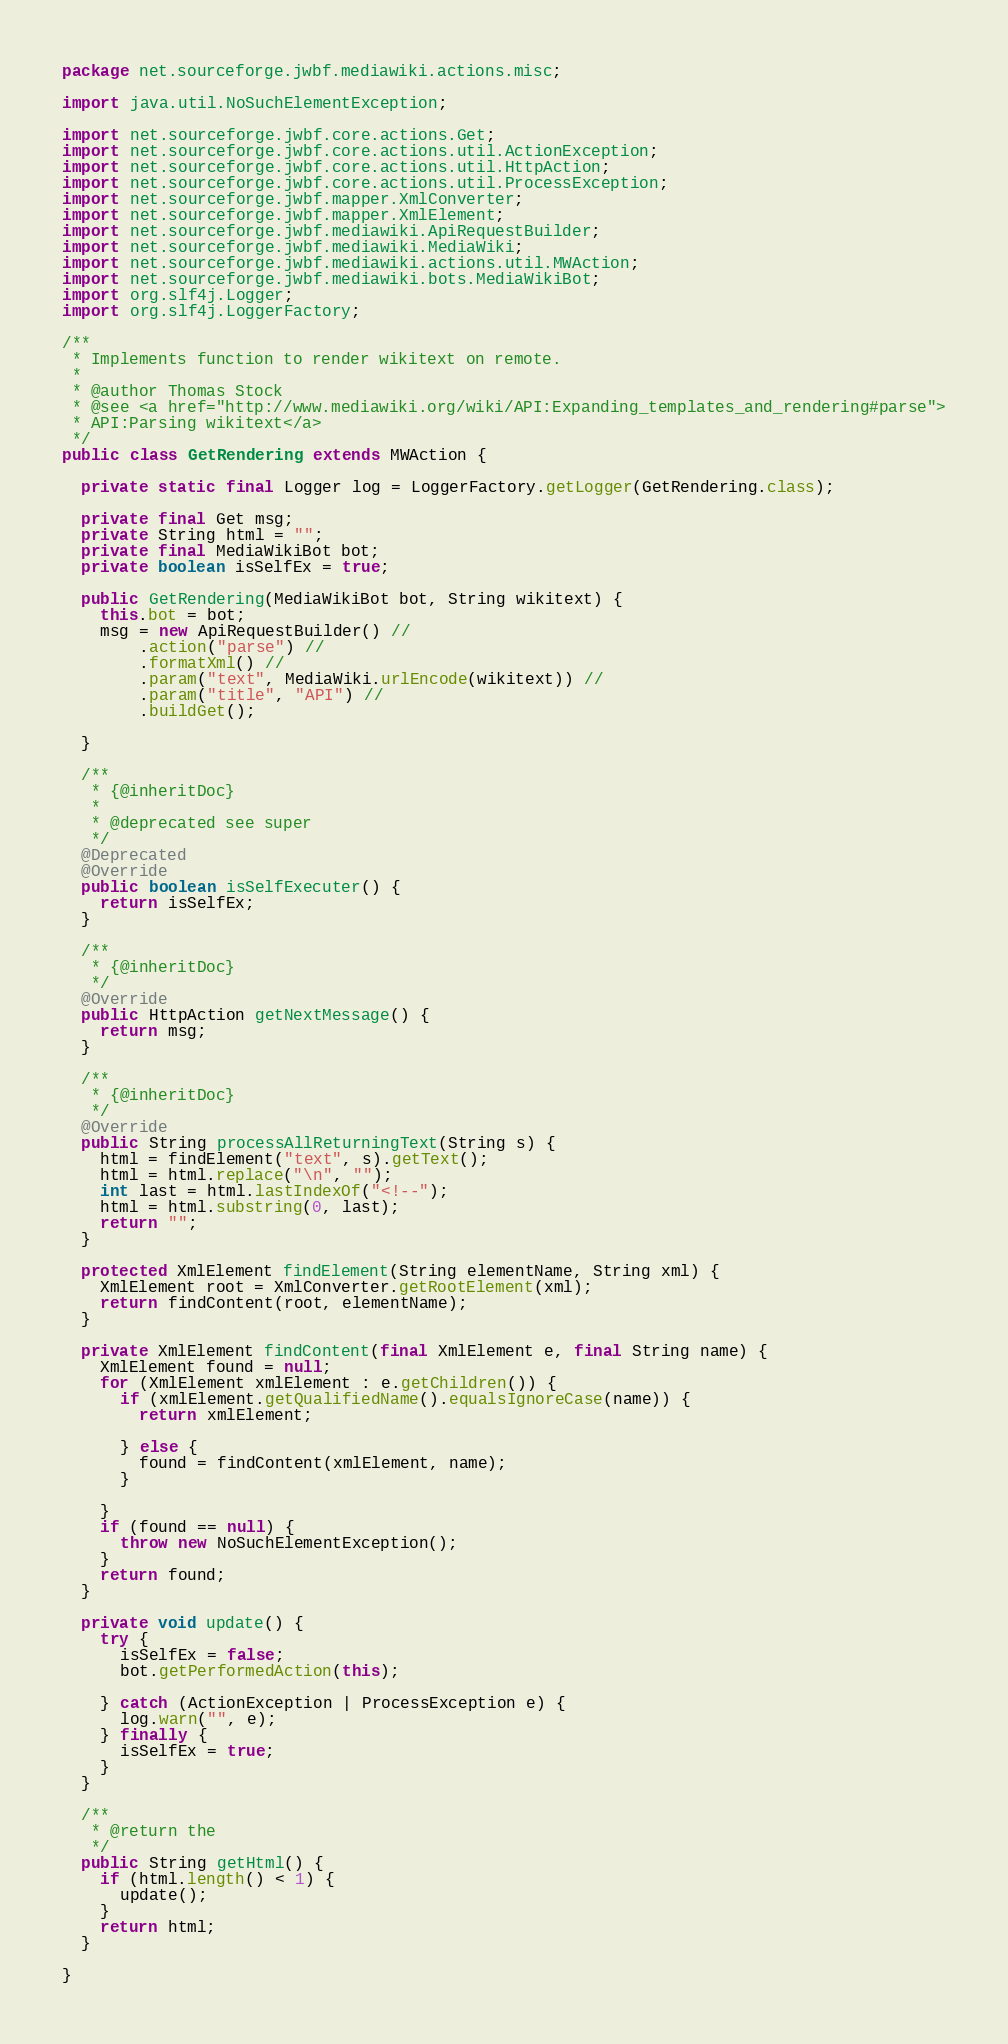<code> <loc_0><loc_0><loc_500><loc_500><_Java_>package net.sourceforge.jwbf.mediawiki.actions.misc;

import java.util.NoSuchElementException;

import net.sourceforge.jwbf.core.actions.Get;
import net.sourceforge.jwbf.core.actions.util.ActionException;
import net.sourceforge.jwbf.core.actions.util.HttpAction;
import net.sourceforge.jwbf.core.actions.util.ProcessException;
import net.sourceforge.jwbf.mapper.XmlConverter;
import net.sourceforge.jwbf.mapper.XmlElement;
import net.sourceforge.jwbf.mediawiki.ApiRequestBuilder;
import net.sourceforge.jwbf.mediawiki.MediaWiki;
import net.sourceforge.jwbf.mediawiki.actions.util.MWAction;
import net.sourceforge.jwbf.mediawiki.bots.MediaWikiBot;
import org.slf4j.Logger;
import org.slf4j.LoggerFactory;

/**
 * Implements function to render wikitext on remote.
 *
 * @author Thomas Stock
 * @see <a href="http://www.mediawiki.org/wiki/API:Expanding_templates_and_rendering#parse">
 * API:Parsing wikitext</a>
 */
public class GetRendering extends MWAction {

  private static final Logger log = LoggerFactory.getLogger(GetRendering.class);

  private final Get msg;
  private String html = "";
  private final MediaWikiBot bot;
  private boolean isSelfEx = true;

  public GetRendering(MediaWikiBot bot, String wikitext) {
    this.bot = bot;
    msg = new ApiRequestBuilder() //
        .action("parse") //
        .formatXml() //
        .param("text", MediaWiki.urlEncode(wikitext)) //
        .param("title", "API") //
        .buildGet();

  }

  /**
   * {@inheritDoc}
   *
   * @deprecated see super
   */
  @Deprecated
  @Override
  public boolean isSelfExecuter() {
    return isSelfEx;
  }

  /**
   * {@inheritDoc}
   */
  @Override
  public HttpAction getNextMessage() {
    return msg;
  }

  /**
   * {@inheritDoc}
   */
  @Override
  public String processAllReturningText(String s) {
    html = findElement("text", s).getText();
    html = html.replace("\n", "");
    int last = html.lastIndexOf("<!--");
    html = html.substring(0, last);
    return "";
  }

  protected XmlElement findElement(String elementName, String xml) {
    XmlElement root = XmlConverter.getRootElement(xml);
    return findContent(root, elementName);
  }

  private XmlElement findContent(final XmlElement e, final String name) {
    XmlElement found = null;
    for (XmlElement xmlElement : e.getChildren()) {
      if (xmlElement.getQualifiedName().equalsIgnoreCase(name)) {
        return xmlElement;

      } else {
        found = findContent(xmlElement, name);
      }

    }
    if (found == null) {
      throw new NoSuchElementException();
    }
    return found;
  }

  private void update() {
    try {
      isSelfEx = false;
      bot.getPerformedAction(this);

    } catch (ActionException | ProcessException e) {
      log.warn("", e);
    } finally {
      isSelfEx = true;
    }
  }

  /**
   * @return the
   */
  public String getHtml() {
    if (html.length() < 1) {
      update();
    }
    return html;
  }

}
</code> 